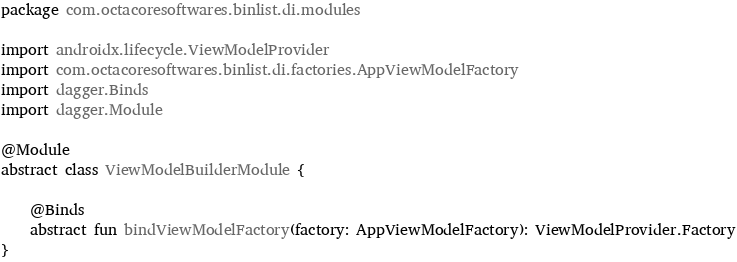Convert code to text. <code><loc_0><loc_0><loc_500><loc_500><_Kotlin_>package com.octacoresoftwares.binlist.di.modules

import androidx.lifecycle.ViewModelProvider
import com.octacoresoftwares.binlist.di.factories.AppViewModelFactory
import dagger.Binds
import dagger.Module

@Module
abstract class ViewModelBuilderModule {

    @Binds
    abstract fun bindViewModelFactory(factory: AppViewModelFactory): ViewModelProvider.Factory
}</code> 